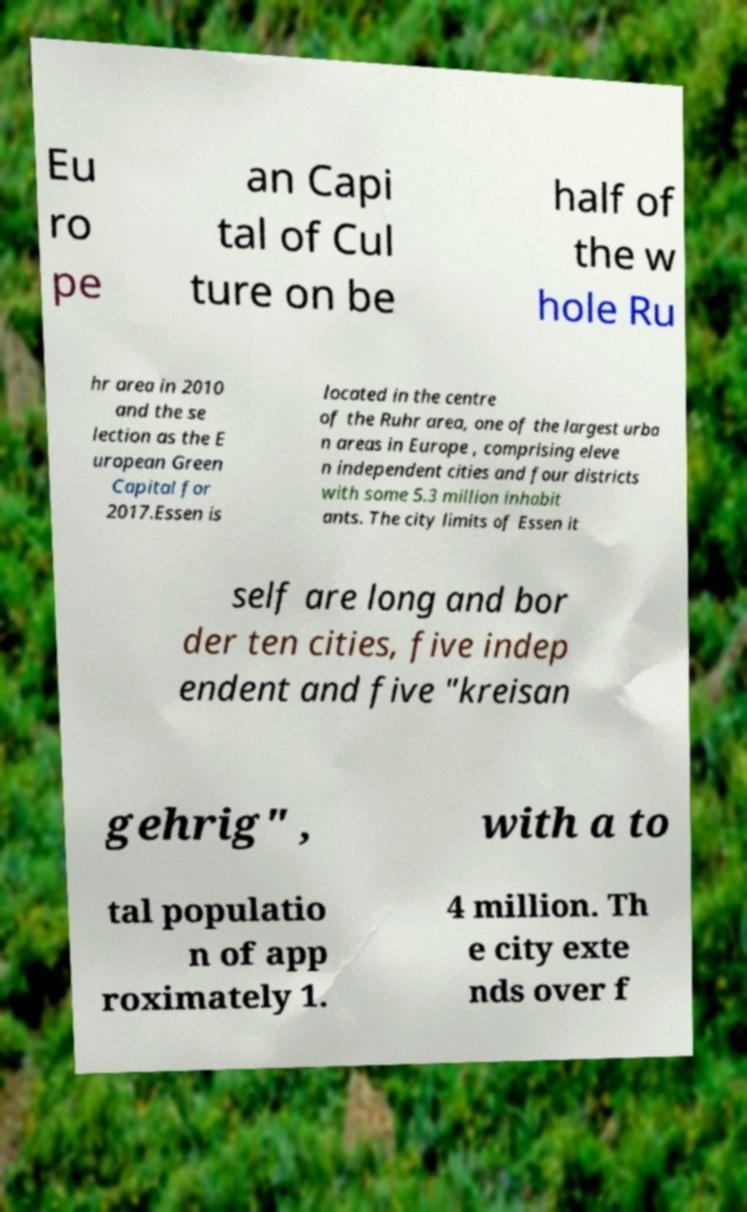Could you extract and type out the text from this image? Eu ro pe an Capi tal of Cul ture on be half of the w hole Ru hr area in 2010 and the se lection as the E uropean Green Capital for 2017.Essen is located in the centre of the Ruhr area, one of the largest urba n areas in Europe , comprising eleve n independent cities and four districts with some 5.3 million inhabit ants. The city limits of Essen it self are long and bor der ten cities, five indep endent and five "kreisan gehrig" , with a to tal populatio n of app roximately 1. 4 million. Th e city exte nds over f 